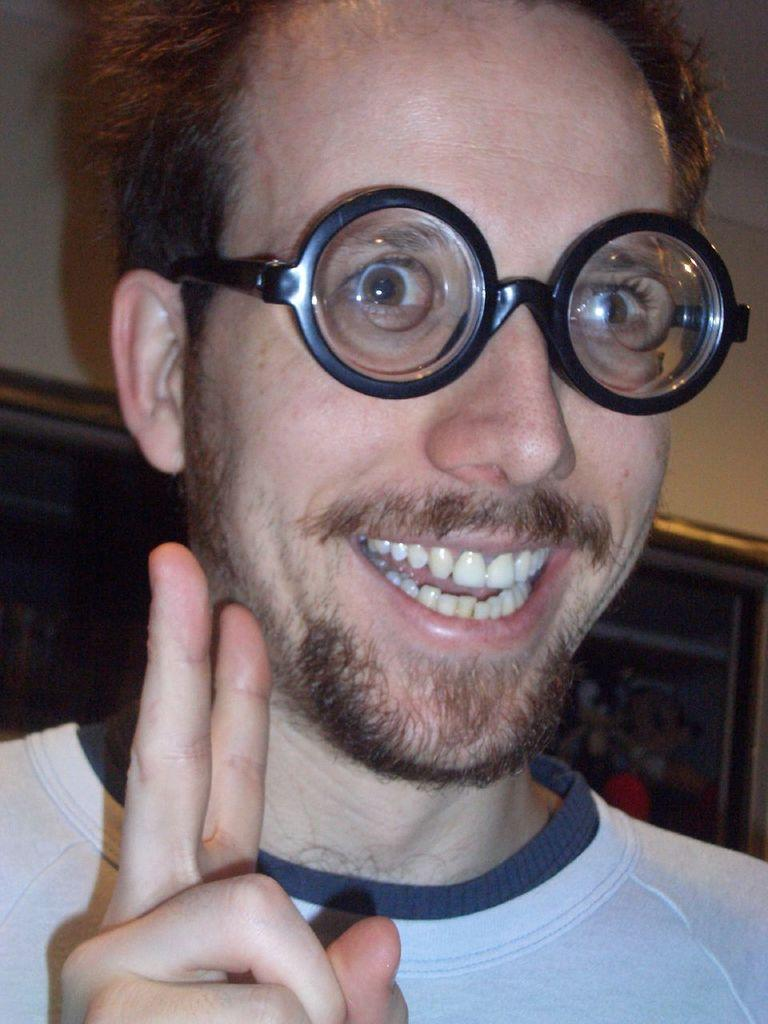What is the person in the image wearing on their face? The person in the image is wearing spectacles. What is the facial expression of the person in the image? The person in the image is smiling. Where is the image located? The image is on a wall. Can you see any sea creatures in the image? There are no sea creatures present in the image; it features a person wearing spectacles and smiling. What type of error is depicted in the image? There is no error depicted in the image; it shows a person wearing spectacles and smiling. 